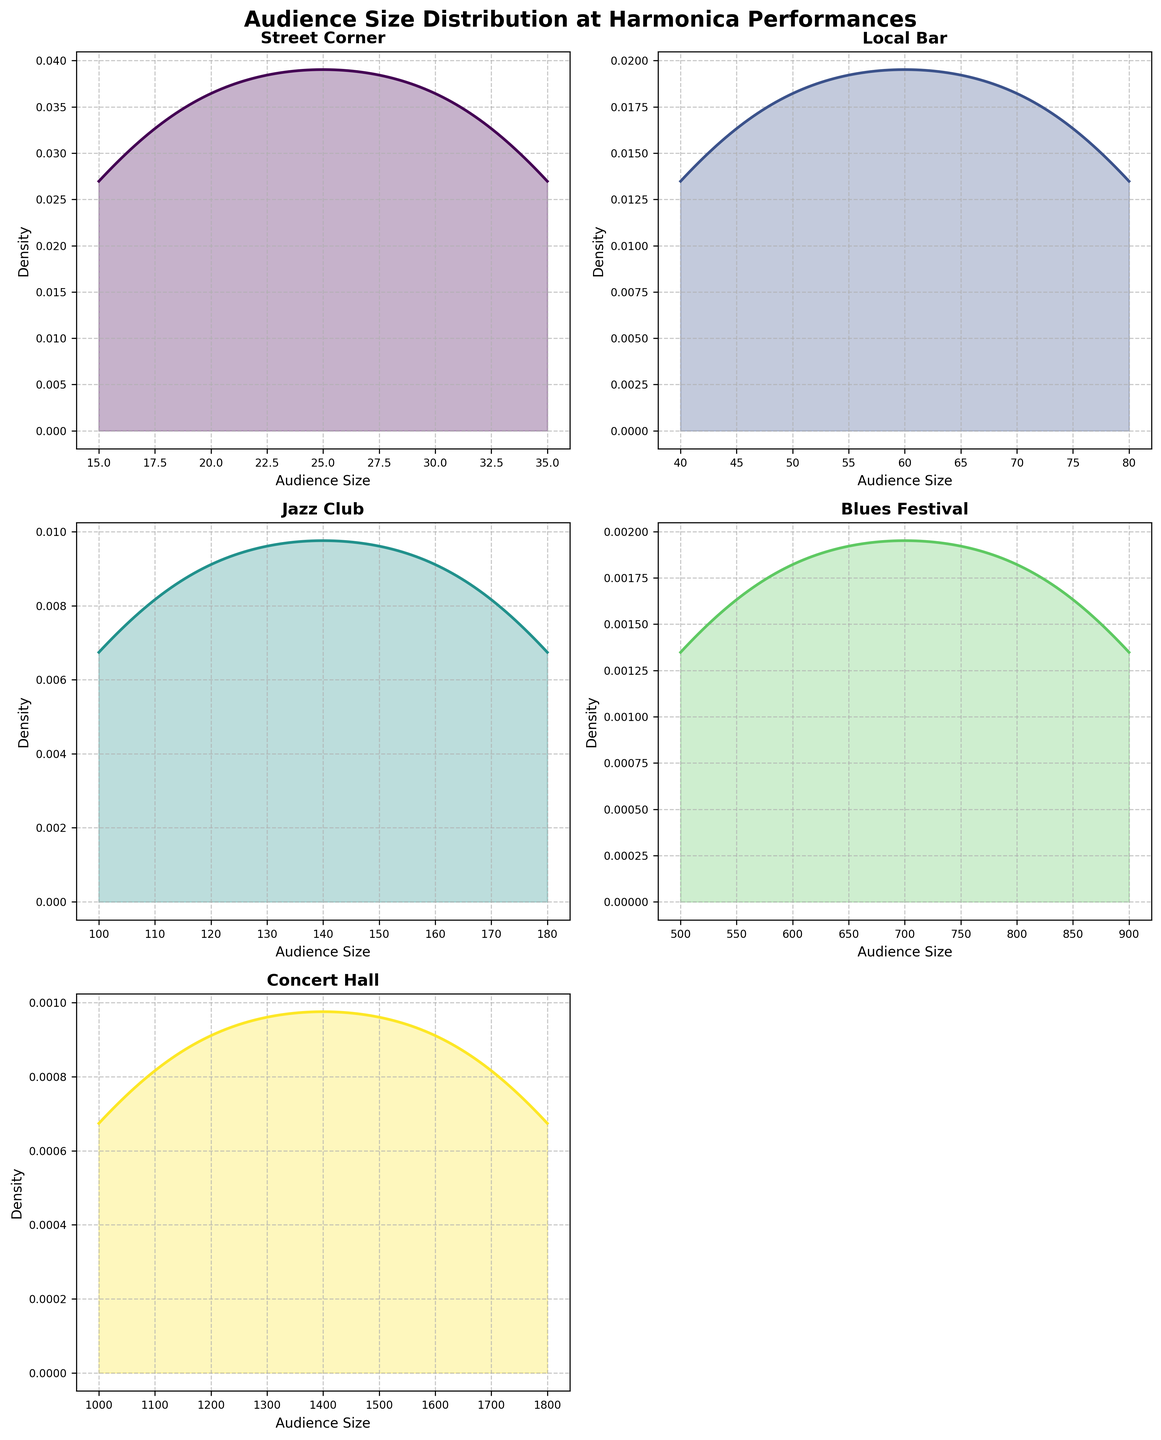What is the title of the figure? The title is located at the top center of the figure and is typically larger and bolder than other text elements. It provides a summary of what the figure represents.
Answer: Audience Size Distribution at Harmonica Performances How many subplots are there in the figure? The figure is arranged in a 3x2 grid, but the bottom-right subplot appears to be empty. Counting the occupied subplots gives us five.
Answer: 5 Which venue has the highest audience size density peak? Look for the density plot with the highest peak on the y-axis. The "Concert Hall" has the highest peak, indicating a larger audience size.
Answer: Concert Hall What is the x-axis label for each subplot? Review the x-axis label below each subplot. They are all labeled consistently with “Audience Size”.
Answer: Audience Size Which venue has the widest range of audience sizes? Compare the ranges of the x-axes in each subplot. The "Concert Hall" spans from 1000 to 1800, which is the widest range.
Answer: Concert Hall Which subplot appears to have the highest density for the smallest audience sizes? Identify the subplot where the density is greatest at the lower end of the x-axis. The "Street Corner" subplot has the highest density at audience sizes between 15 and 35.
Answer: Street Corner Compare the audience size densities of the Jazz Club and Local Bar. Which one has a higher peak density? Look at the peak heights of the density curves for both "Jazz Club" and "Local Bar". The "Jazz Club" has a higher peak compared to the "Local Bar".
Answer: Jazz Club How does the density distribution of the Blues Festival compare to that of the Concert Hall? Both distributions are for large audience sizes, but the "Blues Festival" density is more spread out with a lower peak, while the "Concert Hall" has a narrower and higher peak.
Answer: Blues Festival is more spread out; Concert Hall is narrower and higher Which venues have audience sizes extending beyond 1000? Look at the x-axis ranges for each subplot. Both "Blues Festival" and "Concert Hall" have audience sizes that extend beyond 1000.
Answer: Blues Festival, Concert Hall 